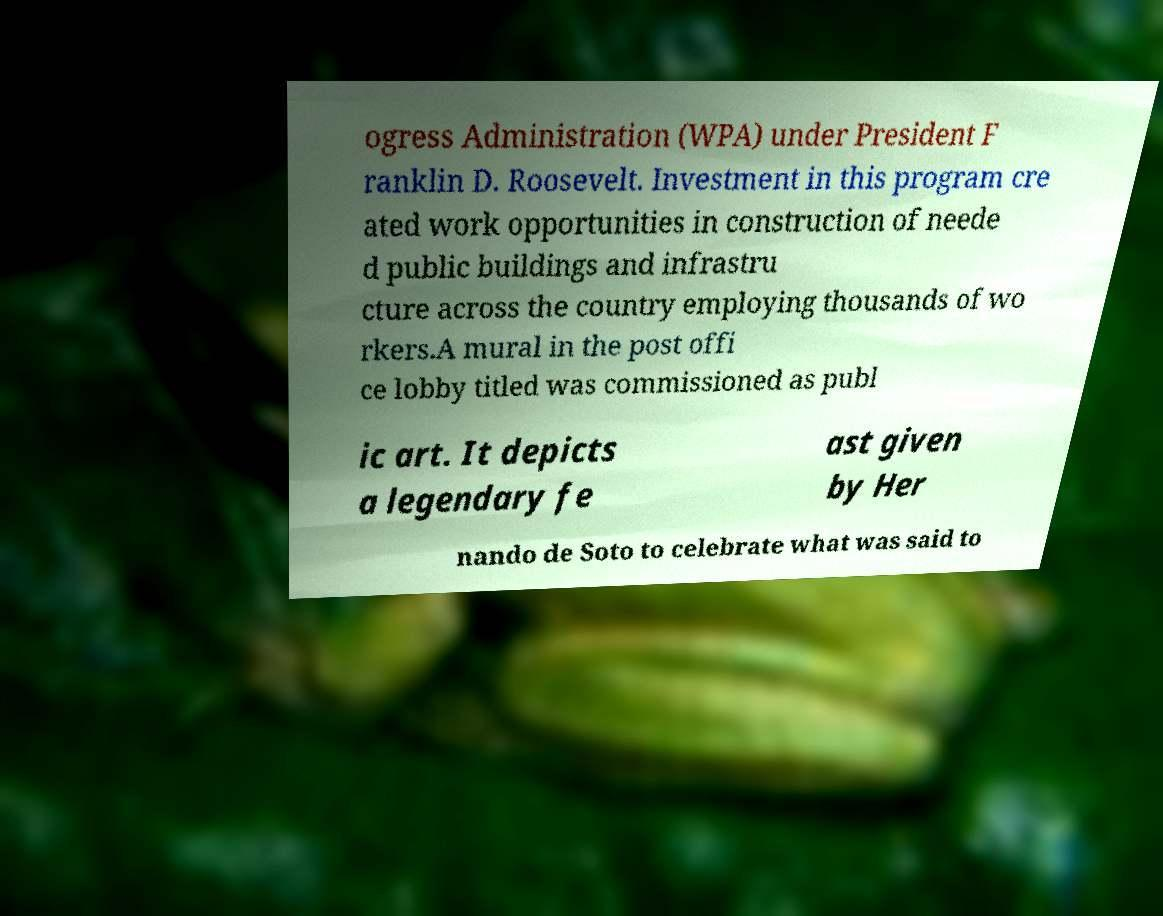I need the written content from this picture converted into text. Can you do that? ogress Administration (WPA) under President F ranklin D. Roosevelt. Investment in this program cre ated work opportunities in construction of neede d public buildings and infrastru cture across the country employing thousands of wo rkers.A mural in the post offi ce lobby titled was commissioned as publ ic art. It depicts a legendary fe ast given by Her nando de Soto to celebrate what was said to 